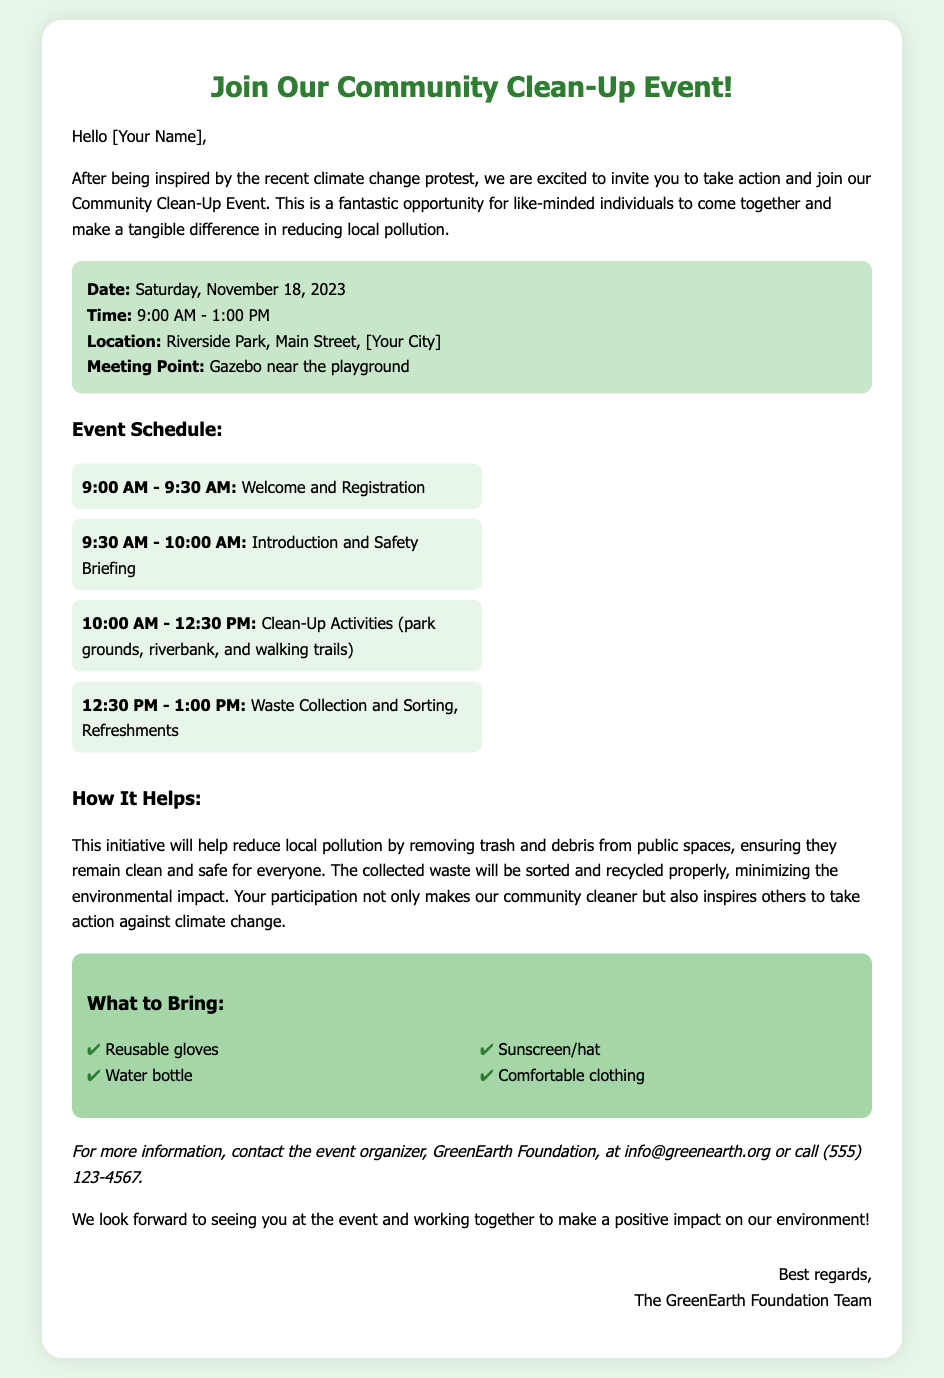what is the date of the event? The date of the event is clearly stated in the document, which is Saturday, November 18, 2023.
Answer: Saturday, November 18, 2023 what time does the clean-up event start? The event's start time is mentioned in the schedule section of the document, which states it begins at 9:00 AM.
Answer: 9:00 AM where will the event take place? The location of the event is specified in the event details, which is Riverside Park, Main Street, [Your City].
Answer: Riverside Park, Main Street, [Your City] what will participants do at 10:00 AM during the event? The schedule indicates that at 10:00 AM, participants will engage in clean-up activities at various locations.
Answer: Clean-Up Activities how will this initiative reduce local pollution? The document explains that the initiative involves removing trash and debris, which helps keep public spaces clean and safe.
Answer: Removing trash and debris what should participants bring to the event? The section on what to bring lists several items recommended for participants, such as reusable gloves and a water bottle.
Answer: Reusable gloves, water bottle who is organizing the event? The contact information at the bottom of the document states the event is organized by the GreenEarth Foundation.
Answer: GreenEarth Foundation what type of clothing is recommended for participants? The document mentions that participants should wear comfortable clothing, which is highlighted in the "What to Bring" section.
Answer: Comfortable clothing 